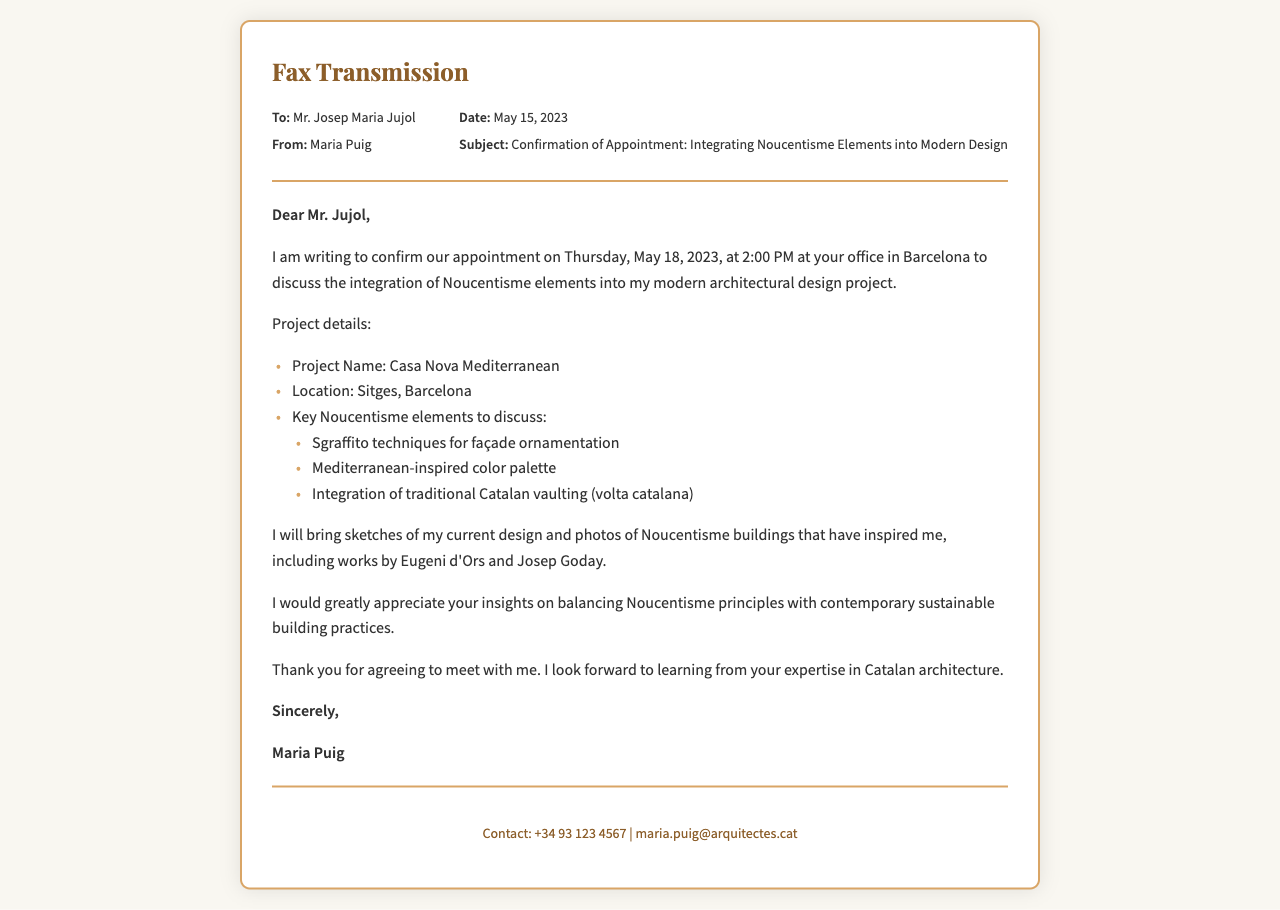What is the date of the appointment? The appointment is scheduled for Thursday, May 18, 2023, as mentioned in the body of the fax.
Answer: May 18, 2023 Who is the recipient of the fax? The fax is addressed to Mr. Josep Maria Jujol, which is specified in the recipient section.
Answer: Mr. Josep Maria Jujol What is the project name? The project is referred to as "Casa Nova Mediterranean" in the document.
Answer: Casa Nova Mediterranean What type of techniques will be discussed? The techniques mentioned are sgraffito techniques for façade ornamentation.
Answer: Sgraffito techniques What did Maria Puig express appreciation for? Maria Puig appreciated Mr. Jujol's insights on balancing Noucentisme principles with contemporary sustainable building practices.
Answer: Insights on balancing Noucentisme principles What is the location of the project? The project is located in Sitges, Barcelona, as listed in the project details.
Answer: Sitges, Barcelona What time is the appointment scheduled for? The appointment is set for 2:00 PM, stated in the body of the fax.
Answer: 2:00 PM What will Maria bring to the meeting? Maria plans to bring sketches of her current design and photos of Noucentisme buildings.
Answer: Sketches and photos What is the subject of the fax? The subject line of the fax states the topic as "Confirmation of Appointment: Integrating Noucentisme Elements into Modern Design."
Answer: Confirmation of Appointment: Integrating Noucentisme Elements into Modern Design 